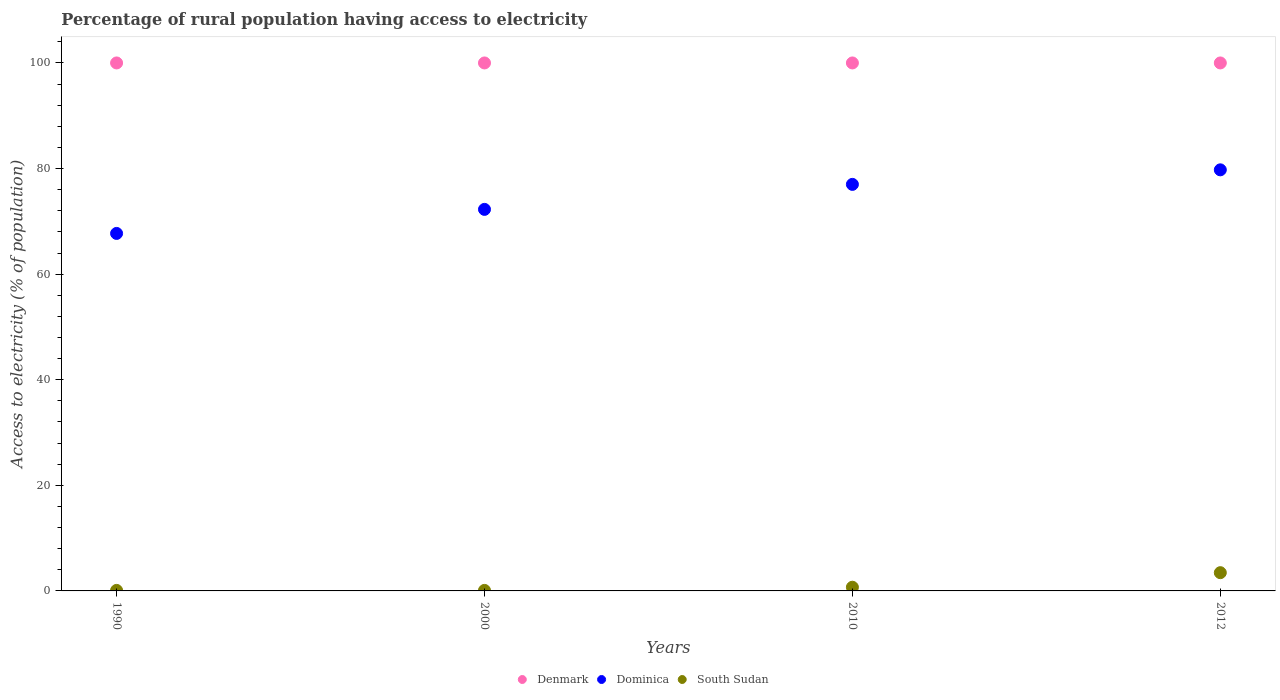How many different coloured dotlines are there?
Make the answer very short. 3. What is the percentage of rural population having access to electricity in South Sudan in 2010?
Ensure brevity in your answer.  0.7. Across all years, what is the maximum percentage of rural population having access to electricity in Denmark?
Offer a terse response. 100. Across all years, what is the minimum percentage of rural population having access to electricity in Denmark?
Provide a succinct answer. 100. What is the total percentage of rural population having access to electricity in South Sudan in the graph?
Make the answer very short. 4.35. What is the difference between the percentage of rural population having access to electricity in South Sudan in 2000 and the percentage of rural population having access to electricity in Denmark in 2012?
Your answer should be very brief. -99.9. What is the average percentage of rural population having access to electricity in South Sudan per year?
Offer a terse response. 1.09. In the year 2000, what is the difference between the percentage of rural population having access to electricity in Denmark and percentage of rural population having access to electricity in Dominica?
Give a very brief answer. 27.73. In how many years, is the percentage of rural population having access to electricity in Denmark greater than 76 %?
Your answer should be very brief. 4. Is the percentage of rural population having access to electricity in Dominica in 2000 less than that in 2012?
Give a very brief answer. Yes. Is the difference between the percentage of rural population having access to electricity in Denmark in 1990 and 2010 greater than the difference between the percentage of rural population having access to electricity in Dominica in 1990 and 2010?
Make the answer very short. Yes. What is the difference between the highest and the second highest percentage of rural population having access to electricity in Denmark?
Make the answer very short. 0. What is the difference between the highest and the lowest percentage of rural population having access to electricity in Denmark?
Your response must be concise. 0. In how many years, is the percentage of rural population having access to electricity in Denmark greater than the average percentage of rural population having access to electricity in Denmark taken over all years?
Keep it short and to the point. 0. Is the sum of the percentage of rural population having access to electricity in South Sudan in 1990 and 2010 greater than the maximum percentage of rural population having access to electricity in Denmark across all years?
Your response must be concise. No. Does the percentage of rural population having access to electricity in South Sudan monotonically increase over the years?
Ensure brevity in your answer.  No. Is the percentage of rural population having access to electricity in Denmark strictly greater than the percentage of rural population having access to electricity in South Sudan over the years?
Provide a succinct answer. Yes. How many dotlines are there?
Your response must be concise. 3. How many years are there in the graph?
Offer a very short reply. 4. Are the values on the major ticks of Y-axis written in scientific E-notation?
Your answer should be compact. No. Does the graph contain any zero values?
Offer a very short reply. No. Where does the legend appear in the graph?
Make the answer very short. Bottom center. How many legend labels are there?
Ensure brevity in your answer.  3. How are the legend labels stacked?
Ensure brevity in your answer.  Horizontal. What is the title of the graph?
Provide a succinct answer. Percentage of rural population having access to electricity. Does "Guyana" appear as one of the legend labels in the graph?
Your response must be concise. No. What is the label or title of the Y-axis?
Make the answer very short. Access to electricity (% of population). What is the Access to electricity (% of population) in Denmark in 1990?
Offer a very short reply. 100. What is the Access to electricity (% of population) of Dominica in 1990?
Your answer should be very brief. 67.71. What is the Access to electricity (% of population) of Dominica in 2000?
Keep it short and to the point. 72.27. What is the Access to electricity (% of population) in South Sudan in 2000?
Offer a terse response. 0.1. What is the Access to electricity (% of population) in Denmark in 2010?
Offer a very short reply. 100. What is the Access to electricity (% of population) in Denmark in 2012?
Offer a terse response. 100. What is the Access to electricity (% of population) in Dominica in 2012?
Give a very brief answer. 79.75. What is the Access to electricity (% of population) of South Sudan in 2012?
Offer a very short reply. 3.45. Across all years, what is the maximum Access to electricity (% of population) of Denmark?
Provide a succinct answer. 100. Across all years, what is the maximum Access to electricity (% of population) of Dominica?
Give a very brief answer. 79.75. Across all years, what is the maximum Access to electricity (% of population) in South Sudan?
Provide a short and direct response. 3.45. Across all years, what is the minimum Access to electricity (% of population) of Dominica?
Your answer should be very brief. 67.71. What is the total Access to electricity (% of population) of Dominica in the graph?
Offer a very short reply. 296.73. What is the total Access to electricity (% of population) in South Sudan in the graph?
Keep it short and to the point. 4.35. What is the difference between the Access to electricity (% of population) of Dominica in 1990 and that in 2000?
Ensure brevity in your answer.  -4.55. What is the difference between the Access to electricity (% of population) in Dominica in 1990 and that in 2010?
Keep it short and to the point. -9.29. What is the difference between the Access to electricity (% of population) in South Sudan in 1990 and that in 2010?
Provide a short and direct response. -0.6. What is the difference between the Access to electricity (% of population) of Denmark in 1990 and that in 2012?
Make the answer very short. 0. What is the difference between the Access to electricity (% of population) in Dominica in 1990 and that in 2012?
Give a very brief answer. -12.04. What is the difference between the Access to electricity (% of population) in South Sudan in 1990 and that in 2012?
Your response must be concise. -3.35. What is the difference between the Access to electricity (% of population) in Dominica in 2000 and that in 2010?
Provide a short and direct response. -4.74. What is the difference between the Access to electricity (% of population) in South Sudan in 2000 and that in 2010?
Ensure brevity in your answer.  -0.6. What is the difference between the Access to electricity (% of population) in Dominica in 2000 and that in 2012?
Make the answer very short. -7.49. What is the difference between the Access to electricity (% of population) in South Sudan in 2000 and that in 2012?
Your response must be concise. -3.35. What is the difference between the Access to electricity (% of population) in Dominica in 2010 and that in 2012?
Offer a very short reply. -2.75. What is the difference between the Access to electricity (% of population) of South Sudan in 2010 and that in 2012?
Provide a short and direct response. -2.75. What is the difference between the Access to electricity (% of population) of Denmark in 1990 and the Access to electricity (% of population) of Dominica in 2000?
Offer a terse response. 27.73. What is the difference between the Access to electricity (% of population) in Denmark in 1990 and the Access to electricity (% of population) in South Sudan in 2000?
Your response must be concise. 99.9. What is the difference between the Access to electricity (% of population) of Dominica in 1990 and the Access to electricity (% of population) of South Sudan in 2000?
Your answer should be very brief. 67.61. What is the difference between the Access to electricity (% of population) of Denmark in 1990 and the Access to electricity (% of population) of South Sudan in 2010?
Ensure brevity in your answer.  99.3. What is the difference between the Access to electricity (% of population) of Dominica in 1990 and the Access to electricity (% of population) of South Sudan in 2010?
Provide a succinct answer. 67.01. What is the difference between the Access to electricity (% of population) in Denmark in 1990 and the Access to electricity (% of population) in Dominica in 2012?
Provide a short and direct response. 20.25. What is the difference between the Access to electricity (% of population) of Denmark in 1990 and the Access to electricity (% of population) of South Sudan in 2012?
Offer a terse response. 96.55. What is the difference between the Access to electricity (% of population) in Dominica in 1990 and the Access to electricity (% of population) in South Sudan in 2012?
Your response must be concise. 64.26. What is the difference between the Access to electricity (% of population) of Denmark in 2000 and the Access to electricity (% of population) of Dominica in 2010?
Offer a terse response. 23. What is the difference between the Access to electricity (% of population) in Denmark in 2000 and the Access to electricity (% of population) in South Sudan in 2010?
Offer a very short reply. 99.3. What is the difference between the Access to electricity (% of population) in Dominica in 2000 and the Access to electricity (% of population) in South Sudan in 2010?
Make the answer very short. 71.56. What is the difference between the Access to electricity (% of population) of Denmark in 2000 and the Access to electricity (% of population) of Dominica in 2012?
Provide a succinct answer. 20.25. What is the difference between the Access to electricity (% of population) in Denmark in 2000 and the Access to electricity (% of population) in South Sudan in 2012?
Your response must be concise. 96.55. What is the difference between the Access to electricity (% of population) in Dominica in 2000 and the Access to electricity (% of population) in South Sudan in 2012?
Ensure brevity in your answer.  68.81. What is the difference between the Access to electricity (% of population) of Denmark in 2010 and the Access to electricity (% of population) of Dominica in 2012?
Offer a very short reply. 20.25. What is the difference between the Access to electricity (% of population) in Denmark in 2010 and the Access to electricity (% of population) in South Sudan in 2012?
Ensure brevity in your answer.  96.55. What is the difference between the Access to electricity (% of population) of Dominica in 2010 and the Access to electricity (% of population) of South Sudan in 2012?
Provide a short and direct response. 73.55. What is the average Access to electricity (% of population) of Dominica per year?
Offer a terse response. 74.18. What is the average Access to electricity (% of population) in South Sudan per year?
Your answer should be very brief. 1.09. In the year 1990, what is the difference between the Access to electricity (% of population) in Denmark and Access to electricity (% of population) in Dominica?
Provide a short and direct response. 32.29. In the year 1990, what is the difference between the Access to electricity (% of population) in Denmark and Access to electricity (% of population) in South Sudan?
Offer a very short reply. 99.9. In the year 1990, what is the difference between the Access to electricity (% of population) of Dominica and Access to electricity (% of population) of South Sudan?
Your answer should be compact. 67.61. In the year 2000, what is the difference between the Access to electricity (% of population) of Denmark and Access to electricity (% of population) of Dominica?
Provide a succinct answer. 27.73. In the year 2000, what is the difference between the Access to electricity (% of population) of Denmark and Access to electricity (% of population) of South Sudan?
Offer a very short reply. 99.9. In the year 2000, what is the difference between the Access to electricity (% of population) of Dominica and Access to electricity (% of population) of South Sudan?
Give a very brief answer. 72.17. In the year 2010, what is the difference between the Access to electricity (% of population) of Denmark and Access to electricity (% of population) of Dominica?
Your answer should be compact. 23. In the year 2010, what is the difference between the Access to electricity (% of population) in Denmark and Access to electricity (% of population) in South Sudan?
Offer a terse response. 99.3. In the year 2010, what is the difference between the Access to electricity (% of population) of Dominica and Access to electricity (% of population) of South Sudan?
Offer a very short reply. 76.3. In the year 2012, what is the difference between the Access to electricity (% of population) of Denmark and Access to electricity (% of population) of Dominica?
Give a very brief answer. 20.25. In the year 2012, what is the difference between the Access to electricity (% of population) of Denmark and Access to electricity (% of population) of South Sudan?
Your answer should be very brief. 96.55. In the year 2012, what is the difference between the Access to electricity (% of population) in Dominica and Access to electricity (% of population) in South Sudan?
Make the answer very short. 76.3. What is the ratio of the Access to electricity (% of population) of Dominica in 1990 to that in 2000?
Make the answer very short. 0.94. What is the ratio of the Access to electricity (% of population) of South Sudan in 1990 to that in 2000?
Offer a terse response. 1. What is the ratio of the Access to electricity (% of population) of Denmark in 1990 to that in 2010?
Provide a short and direct response. 1. What is the ratio of the Access to electricity (% of population) of Dominica in 1990 to that in 2010?
Your response must be concise. 0.88. What is the ratio of the Access to electricity (% of population) in South Sudan in 1990 to that in 2010?
Your answer should be very brief. 0.14. What is the ratio of the Access to electricity (% of population) of Denmark in 1990 to that in 2012?
Make the answer very short. 1. What is the ratio of the Access to electricity (% of population) of Dominica in 1990 to that in 2012?
Keep it short and to the point. 0.85. What is the ratio of the Access to electricity (% of population) in South Sudan in 1990 to that in 2012?
Give a very brief answer. 0.03. What is the ratio of the Access to electricity (% of population) of Dominica in 2000 to that in 2010?
Make the answer very short. 0.94. What is the ratio of the Access to electricity (% of population) in South Sudan in 2000 to that in 2010?
Offer a terse response. 0.14. What is the ratio of the Access to electricity (% of population) in Dominica in 2000 to that in 2012?
Offer a very short reply. 0.91. What is the ratio of the Access to electricity (% of population) in South Sudan in 2000 to that in 2012?
Offer a very short reply. 0.03. What is the ratio of the Access to electricity (% of population) of Denmark in 2010 to that in 2012?
Your response must be concise. 1. What is the ratio of the Access to electricity (% of population) in Dominica in 2010 to that in 2012?
Give a very brief answer. 0.97. What is the ratio of the Access to electricity (% of population) of South Sudan in 2010 to that in 2012?
Provide a short and direct response. 0.2. What is the difference between the highest and the second highest Access to electricity (% of population) of Denmark?
Keep it short and to the point. 0. What is the difference between the highest and the second highest Access to electricity (% of population) of Dominica?
Ensure brevity in your answer.  2.75. What is the difference between the highest and the second highest Access to electricity (% of population) in South Sudan?
Ensure brevity in your answer.  2.75. What is the difference between the highest and the lowest Access to electricity (% of population) of Dominica?
Give a very brief answer. 12.04. What is the difference between the highest and the lowest Access to electricity (% of population) of South Sudan?
Provide a short and direct response. 3.35. 